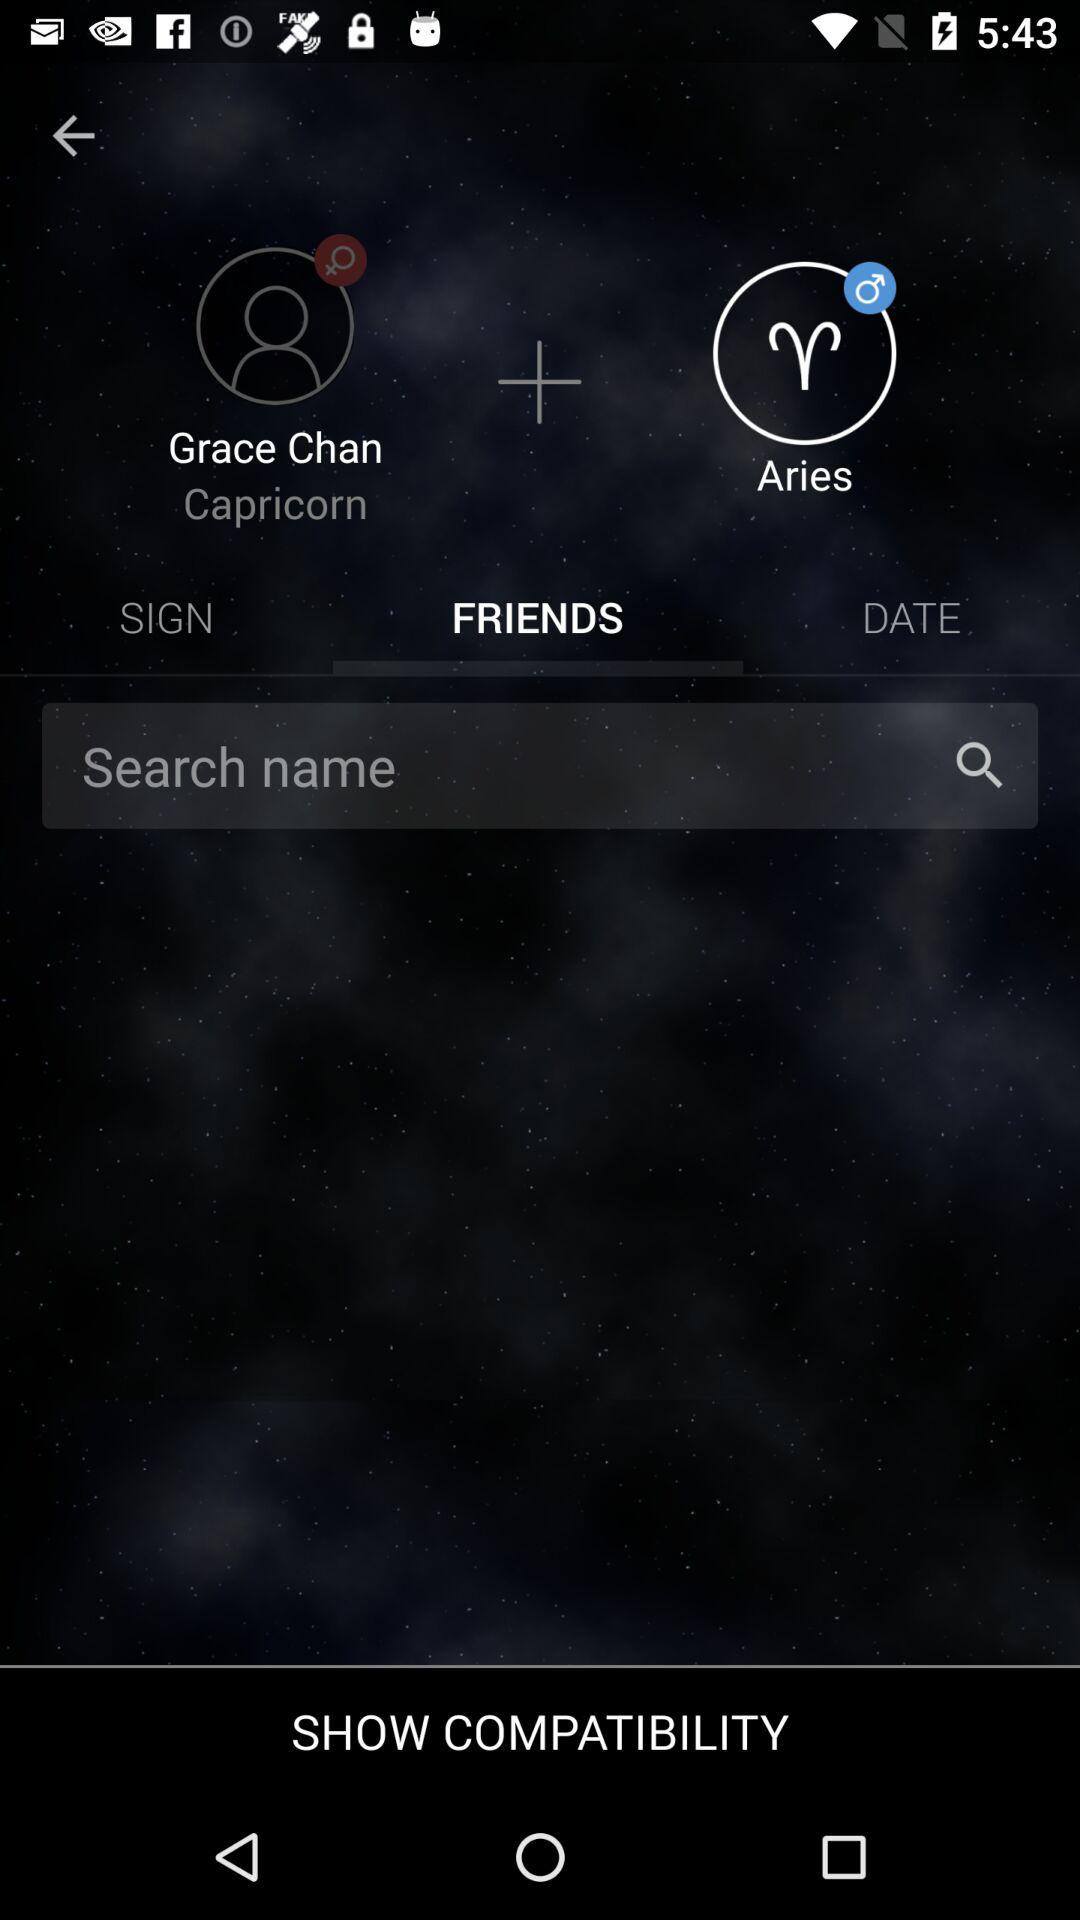Which tab has been selected? The selected tab is "FRIENDS". 